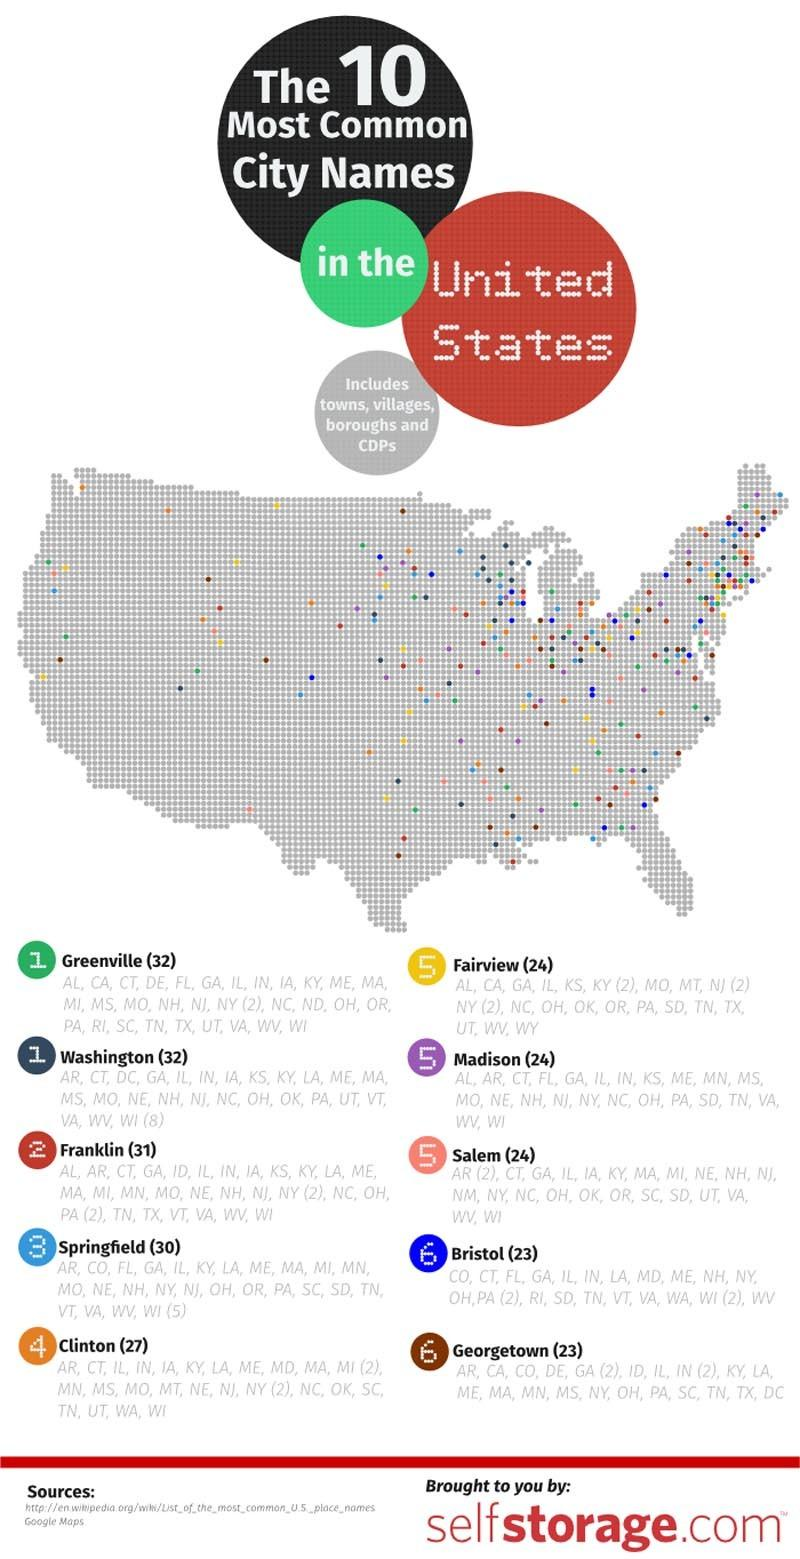Draw attention to some important aspects in this diagram. An observer in Greenville, South Carolina would likely see a variety of bubbles in different colors, including yellow, green, red, and violet. The color of a bubble depends on its size and the substance it is made of, and can range from clear and transparent to opaque and colored. The bubbles in the city of Greenville would likely be affected by the environment and the materials they are made of, leading to the different colors observed. The second town or village code listed under the city of Greenville is CA.. In Franklin city, the color code of towns and villages is orange, blue, red, and brown. Specifically, red. The second town/village code shown under the city of Bristol is CT. The written text inside the green bubble near Greenville is labeled as '1..'. 